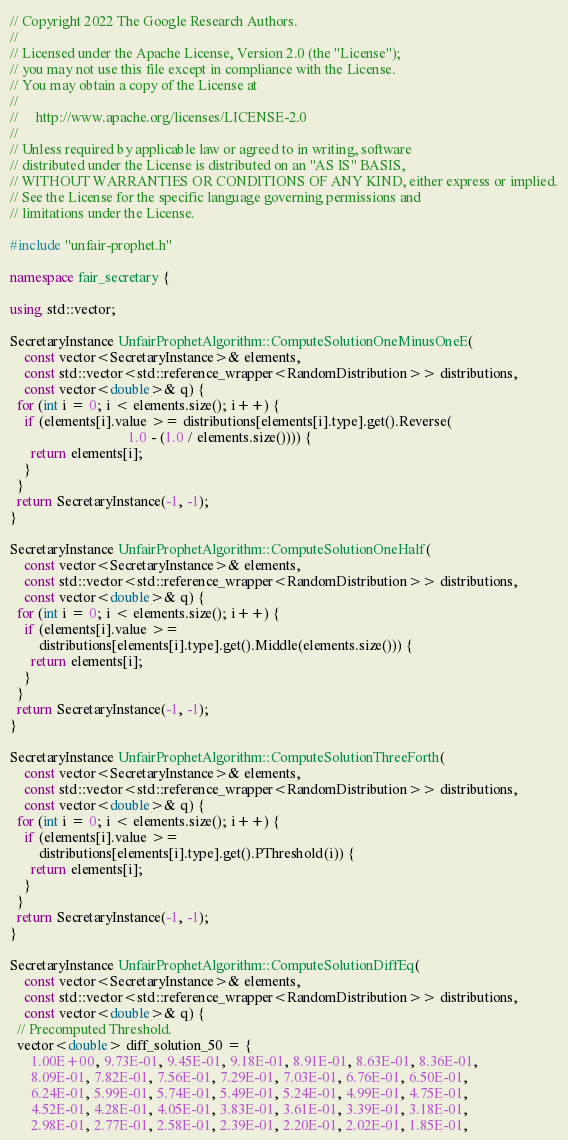<code> <loc_0><loc_0><loc_500><loc_500><_C++_>// Copyright 2022 The Google Research Authors.
//
// Licensed under the Apache License, Version 2.0 (the "License");
// you may not use this file except in compliance with the License.
// You may obtain a copy of the License at
//
//     http://www.apache.org/licenses/LICENSE-2.0
//
// Unless required by applicable law or agreed to in writing, software
// distributed under the License is distributed on an "AS IS" BASIS,
// WITHOUT WARRANTIES OR CONDITIONS OF ANY KIND, either express or implied.
// See the License for the specific language governing permissions and
// limitations under the License.

#include "unfair-prophet.h"

namespace fair_secretary {

using std::vector;

SecretaryInstance UnfairProphetAlgorithm::ComputeSolutionOneMinusOneE(
    const vector<SecretaryInstance>& elements,
    const std::vector<std::reference_wrapper<RandomDistribution>> distributions,
    const vector<double>& q) {
  for (int i = 0; i < elements.size(); i++) {
    if (elements[i].value >= distributions[elements[i].type].get().Reverse(
                                 1.0 - (1.0 / elements.size()))) {
      return elements[i];
    }
  }
  return SecretaryInstance(-1, -1);
}

SecretaryInstance UnfairProphetAlgorithm::ComputeSolutionOneHalf(
    const vector<SecretaryInstance>& elements,
    const std::vector<std::reference_wrapper<RandomDistribution>> distributions,
    const vector<double>& q) {
  for (int i = 0; i < elements.size(); i++) {
    if (elements[i].value >=
        distributions[elements[i].type].get().Middle(elements.size())) {
      return elements[i];
    }
  }
  return SecretaryInstance(-1, -1);
}

SecretaryInstance UnfairProphetAlgorithm::ComputeSolutionThreeForth(
    const vector<SecretaryInstance>& elements,
    const std::vector<std::reference_wrapper<RandomDistribution>> distributions,
    const vector<double>& q) {
  for (int i = 0; i < elements.size(); i++) {
    if (elements[i].value >=
        distributions[elements[i].type].get().PThreshold(i)) {
      return elements[i];
    }
  }
  return SecretaryInstance(-1, -1);
}

SecretaryInstance UnfairProphetAlgorithm::ComputeSolutionDiffEq(
    const vector<SecretaryInstance>& elements,
    const std::vector<std::reference_wrapper<RandomDistribution>> distributions,
    const vector<double>& q) {
  // Precomputed Threshold.
  vector<double> diff_solution_50 = {
      1.00E+00, 9.73E-01, 9.45E-01, 9.18E-01, 8.91E-01, 8.63E-01, 8.36E-01,
      8.09E-01, 7.82E-01, 7.56E-01, 7.29E-01, 7.03E-01, 6.76E-01, 6.50E-01,
      6.24E-01, 5.99E-01, 5.74E-01, 5.49E-01, 5.24E-01, 4.99E-01, 4.75E-01,
      4.52E-01, 4.28E-01, 4.05E-01, 3.83E-01, 3.61E-01, 3.39E-01, 3.18E-01,
      2.98E-01, 2.77E-01, 2.58E-01, 2.39E-01, 2.20E-01, 2.02E-01, 1.85E-01,</code> 